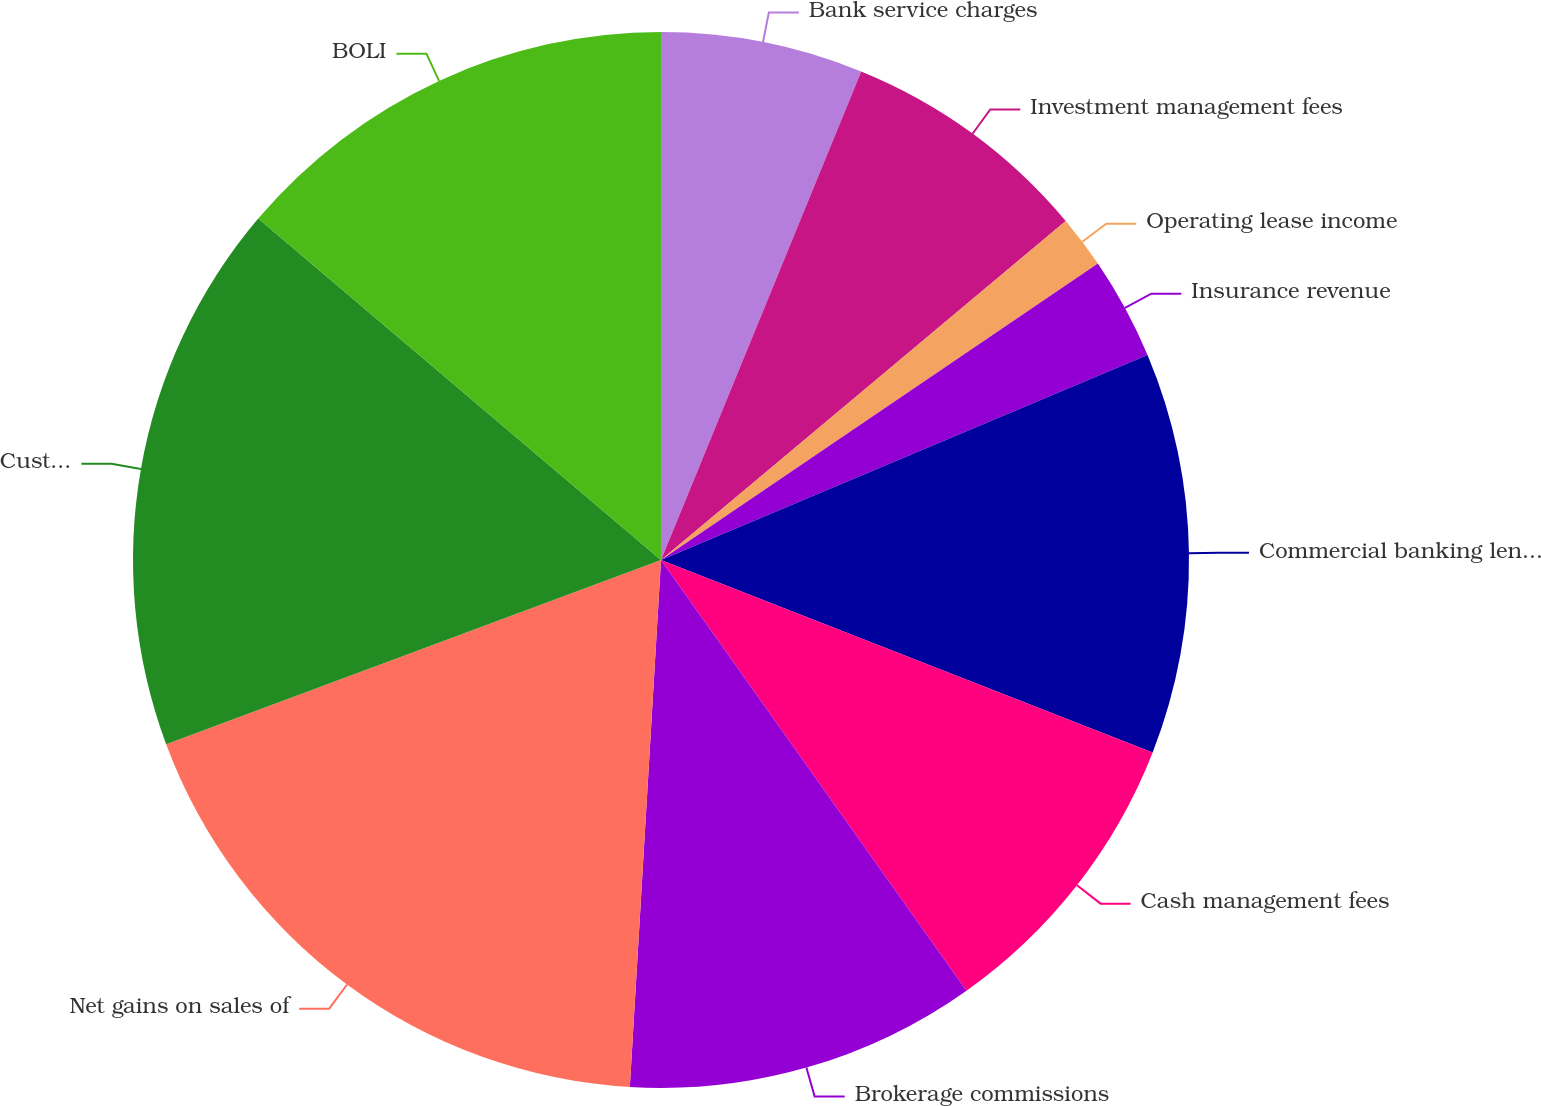<chart> <loc_0><loc_0><loc_500><loc_500><pie_chart><fcel>Bank service charges<fcel>Investment management fees<fcel>Operating lease income<fcel>Insurance revenue<fcel>Commercial banking lending<fcel>Cash management fees<fcel>Brokerage commissions<fcel>Net gains on sales of<fcel>Customer interest rate swap<fcel>BOLI<nl><fcel>6.19%<fcel>7.71%<fcel>1.61%<fcel>3.14%<fcel>12.29%<fcel>9.24%<fcel>10.76%<fcel>18.39%<fcel>16.86%<fcel>13.81%<nl></chart> 